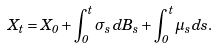Convert formula to latex. <formula><loc_0><loc_0><loc_500><loc_500>X _ { t } = X _ { 0 } + \int _ { 0 } ^ { t } \sigma _ { s } \, d B _ { s } + \int _ { 0 } ^ { t } \mu _ { s } \, d s .</formula> 